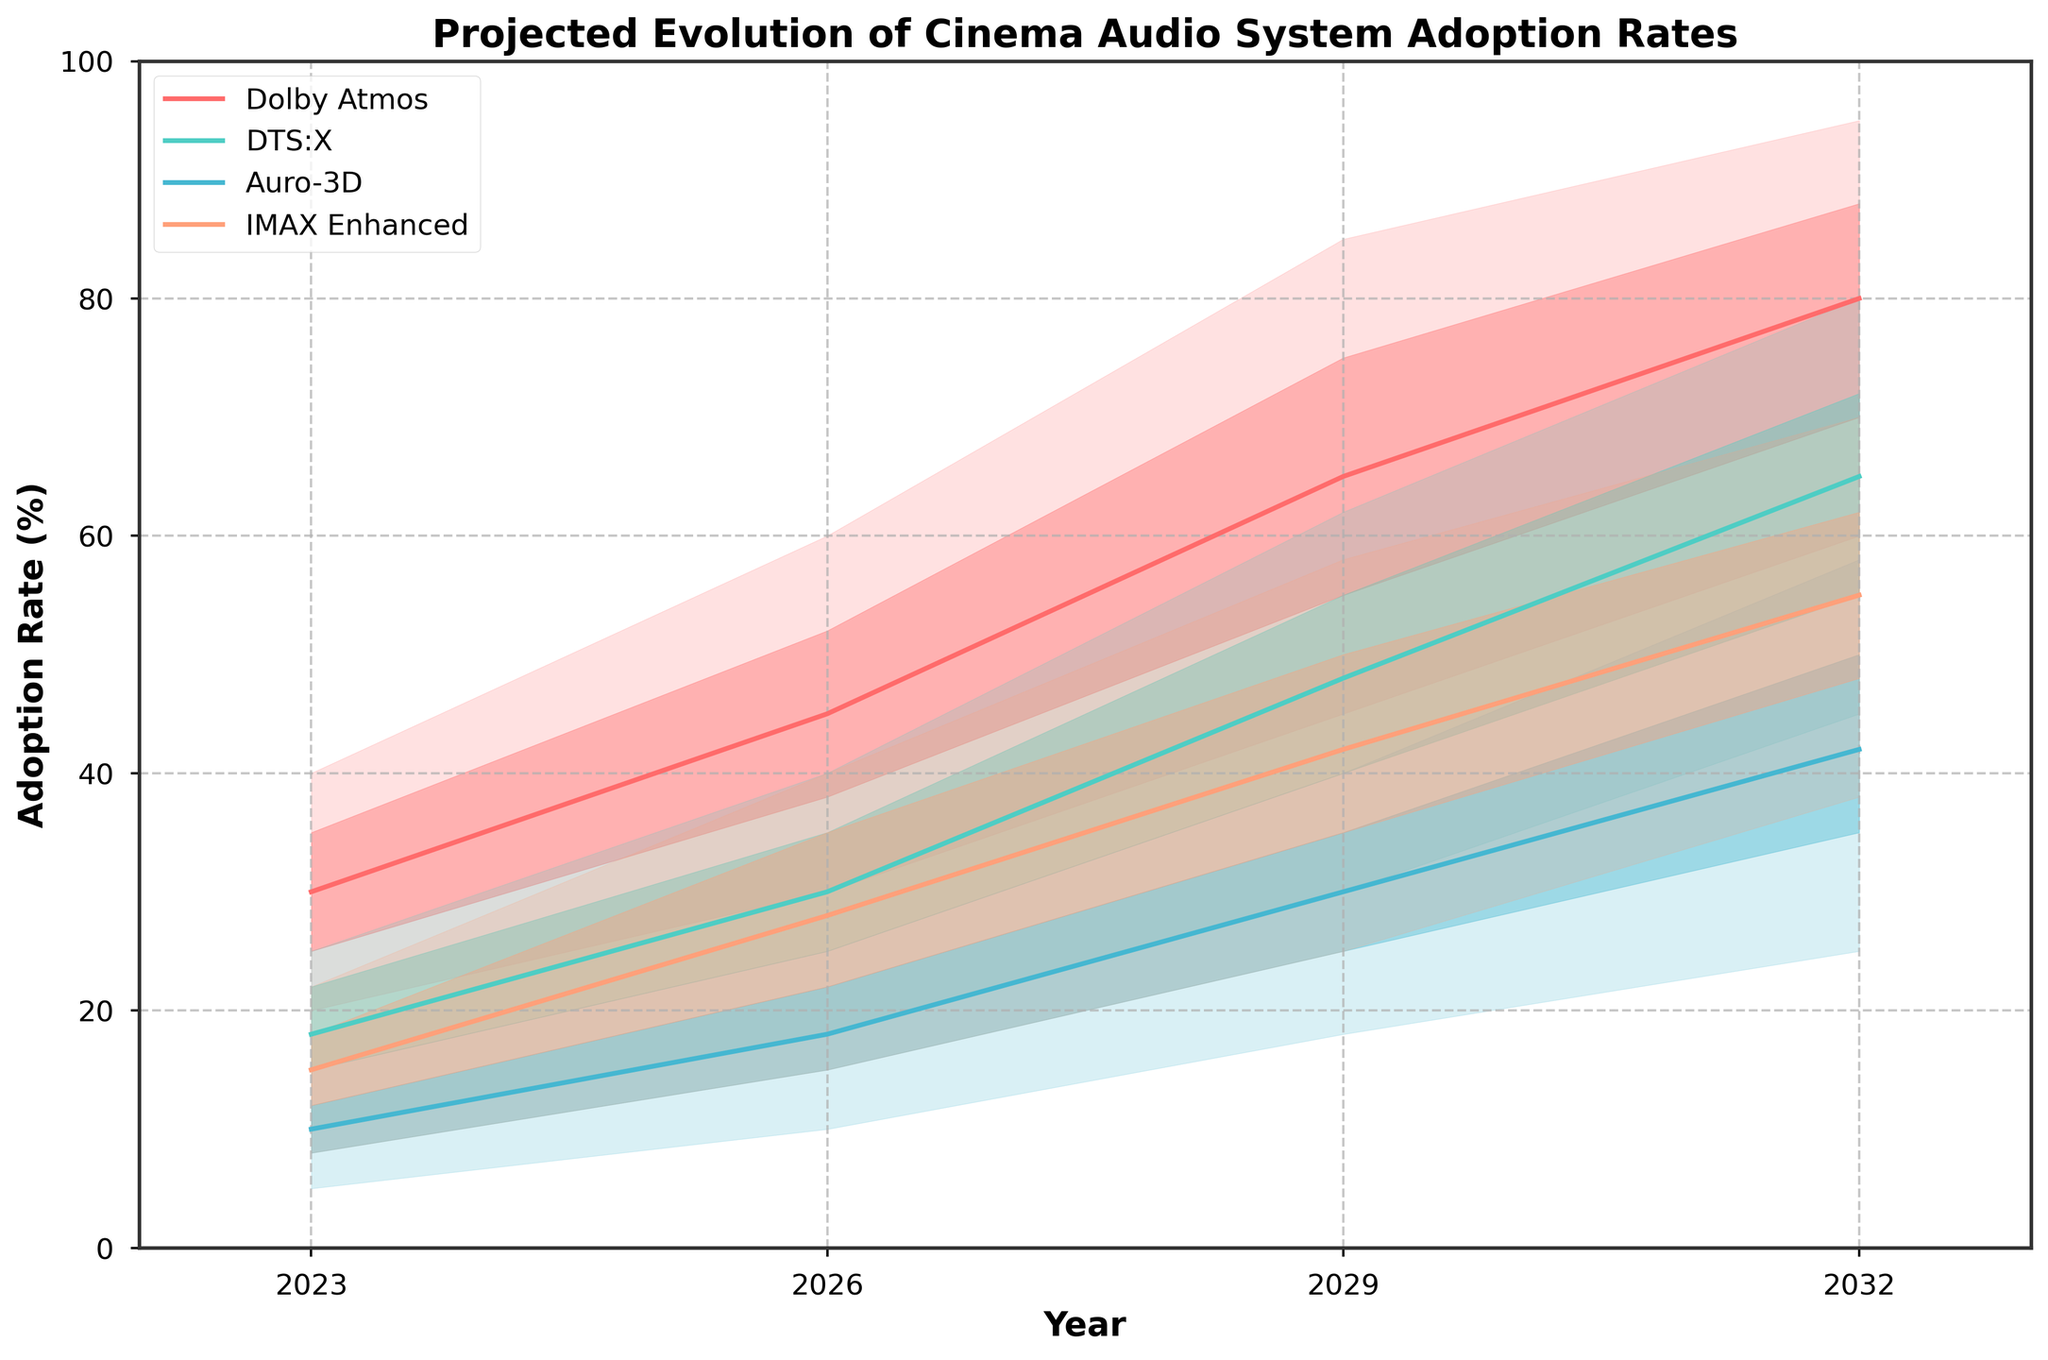What's the title of the figure? The title of a figure is typically placed at the top and provides the main context. In this case, we can see it written at the top in bold text.
Answer: Projected Evolution of Cinema Audio System Adoption Rates What is the projected median adoption rate for Dolby Atmos in 2029? To find this, locate the median line for Dolby Atmos in 2029 and check the value at that point.
Answer: 65% Which technology has the highest projected high adoption rate in 2032? Compare the 'High' values for each technology in 2032 to determine the highest one.
Answer: Dolby Atmos What is the range of projected adoption rates for DTS:X in 2026? Look at the low and high bounds for DTS:X in 2026 and calculate the difference between these values.
Answer: 18% to 40% How does the median adoption rate of IMAX Enhanced change from 2023 to 2029? Locate the median values for IMAX Enhanced in both years and subtract the 2023 value from the 2029 value to find the increase.
Answer: It increases from 15% to 42%, a difference of 27% What are the mid-low and mid-high projected adoption rates for Auro-3D in 2029? Find the mid-low and mid-high values for Auro-3D in 2029 from the data bands.
Answer: Mid-Low: 25%, Mid-High: 35% Which technology is projected to have the lowest median adoption rate in 2032? Compare the median values of all technologies in 2032 to identify the lowest one.
Answer: Auro-3D How do the adoption rates' ranges for Dolby Atmos and DTS:X in 2026 compare? Compare the low and high bounds of both Dolby Atmos and DTS:X in 2026 and determine the difference in the ranges.
Answer: Dolby Atmos: 30% (60 - 30), DTS:X: 22% (40 - 18) What is the projected adoption rate range for IMAX Enhanced in 2029? Look at the values that represent the lowest and highest projected adoption rates for IMAX Enhanced in 2029.
Answer: 25% to 58% How does the adoption rate variance for Dolby Atmos from 2023 to 2032 compare to Auro-3D over the same period? Calculate the variance (difference between high and low values) for both Dolby Atmos and Auro-3D in 2023 and 2032, then compare these variances to show which has a larger range through the years.
Answer: Dolby Atmos variance increases more 